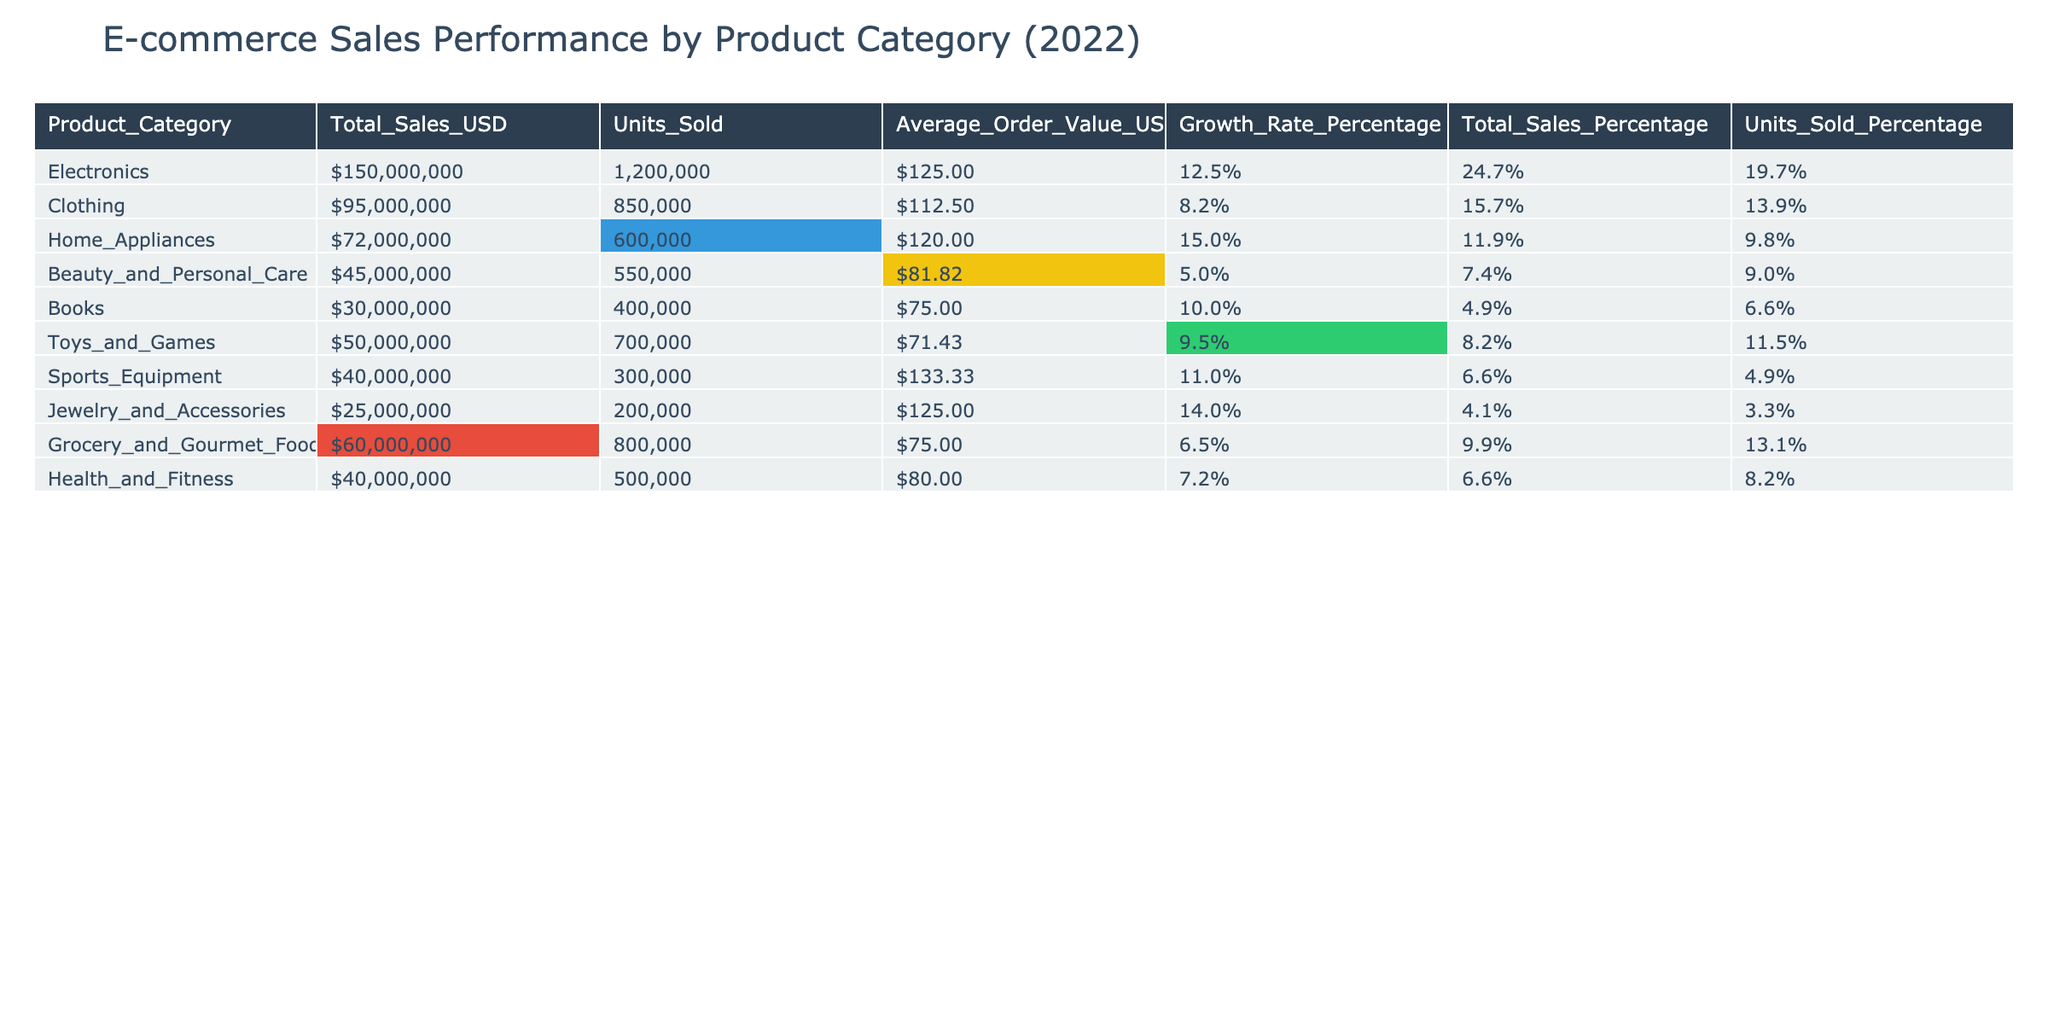What is the total sales in USD for the Electronics category? According to the table, the Total Sales in USD for the Electronics category is directly listed as $150,000,000.
Answer: $150,000,000 Which product category sold the highest number of units? The highest number of units sold is related to Electronics, which sold 1,200,000 units, indicated in the Units Sold column.
Answer: Electronics What was the Average Order Value in USD for the Clothing category? The Average Order Value for the Clothing category is given as $112.50 in the table.
Answer: $112.50 Which product category has the highest Growth Rate percentage? The Growth Rate percentage for Home Appliances is the highest at 15.0%, as shown in the Growth Rate Percentage column.
Answer: Home Appliances How much higher was the Total Sales for Electronics compared to Jewelry and Accessories? The Total Sales for Electronics is $150,000,000 and for Jewelry and Accessories, it is $25,000,000. The difference is calculated as $150,000,000 - $25,000,000 = $125,000,000.
Answer: $125,000,000 What percentage of the total sales does the Beauty and Personal Care category represent? The total sales for all categories sum up to $540,000,000. Beauty and Personal Care is $45,000,000. The percentage is calculated as ($45,000,000 / $540,000,000) * 100 = 8.3%.
Answer: 8.3% Is the Average Order Value for Toys and Games higher than that of Health and Fitness? The Average Order Value for Toys and Games is $71.43 and for Health and Fitness is $80, so Toys and Games has a lower value. Thus, the answer is false.
Answer: No How many total units were sold across all categories? Summing all units sold gives: 1,200,000 + 850,000 + 600,000 + 550,000 + 400,000 + 700,000 + 300,000 + 200,000 + 800,000 + 500,000 = 5,650,000 units total sold.
Answer: 5,650,000 What product category had the lowest Total Sales in USD, and how much was it? The category with the lowest Total Sales is Jewelry and Accessories, which had $25,000,000 in sales, as stated in the Total Sales column.
Answer: Jewelry and Accessories, $25,000,000 If we compare the Average Order Value of Sports Equipment and Electronics, which one is higher, and by how much? The Average Order Value for Sports Equipment is $133.33 and for Electronics is $125.00. The difference is $133.33 - $125.00 = $8.33 more for Sports Equipment.
Answer: Sports Equipment, $8.33 